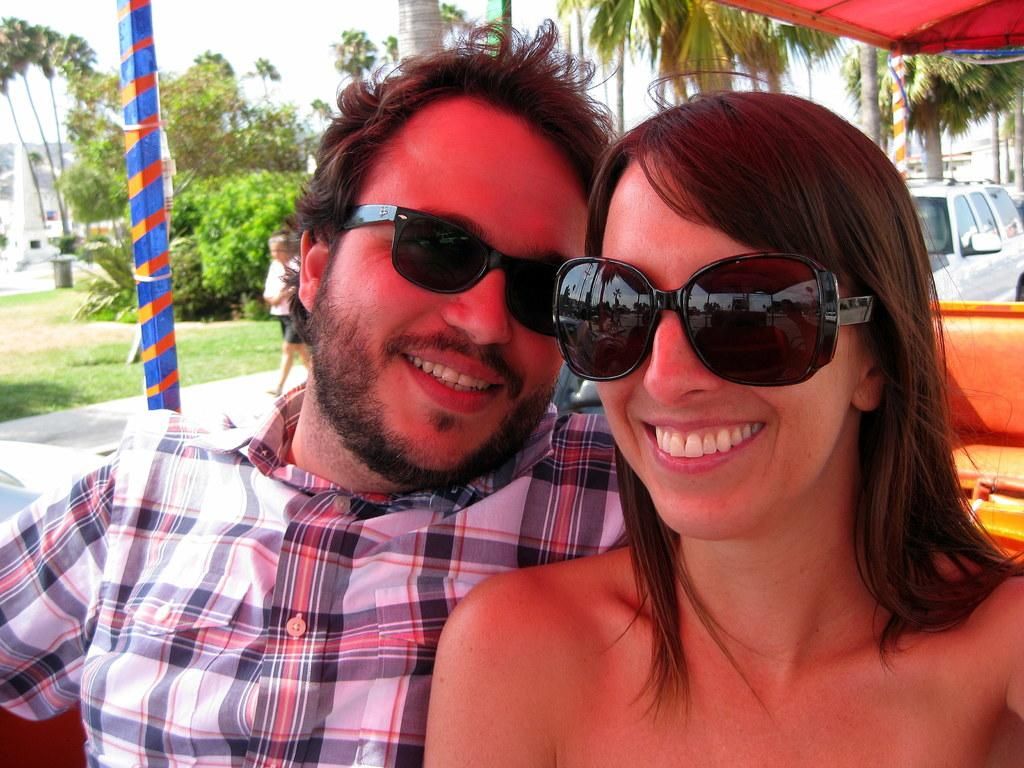Who is present in the image? There is a lady and a man in the image. What are the lady and the man doing? Both the lady and the man are sitting. What expressions do the lady and the man have? Both the lady and the man are smiling. What can be seen in the background of the image? There are trees, poles, a car, a person, a building, and the sky visible in the background of the image. What type of bubble can be seen floating near the lady and the man in the image? There is no bubble present in the image. What kind of apparatus is being used by the person in the background of the image? There is no apparatus visible in the image; only a person, trees, poles, a car, a building, and the sky are present in the background. 